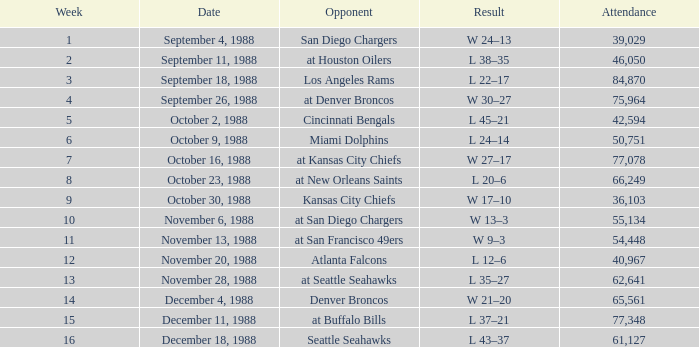What was the date during week 13? November 28, 1988. 